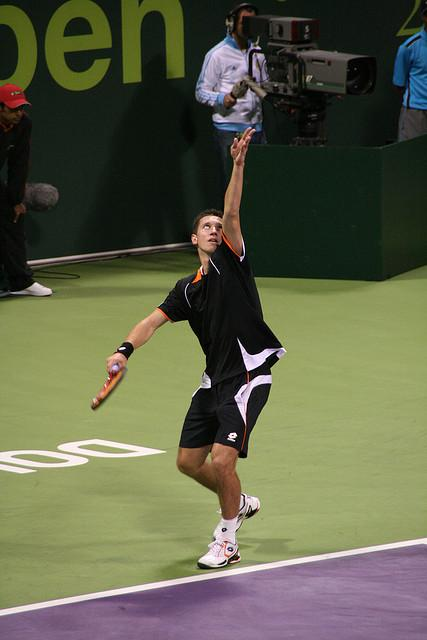What is the player about to do? serve 